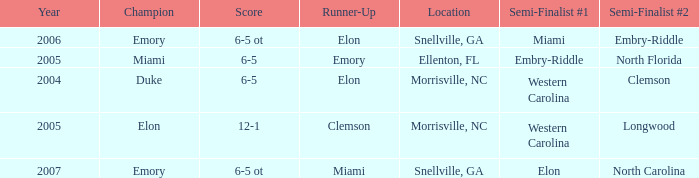Which team was the second semi finalist in 2007? North Carolina. 